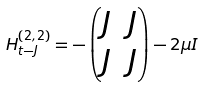Convert formula to latex. <formula><loc_0><loc_0><loc_500><loc_500>H _ { t - J } ^ { \left ( 2 , 2 \right ) } = - \begin{pmatrix} J & J \\ J & J \end{pmatrix} - 2 \mu I</formula> 